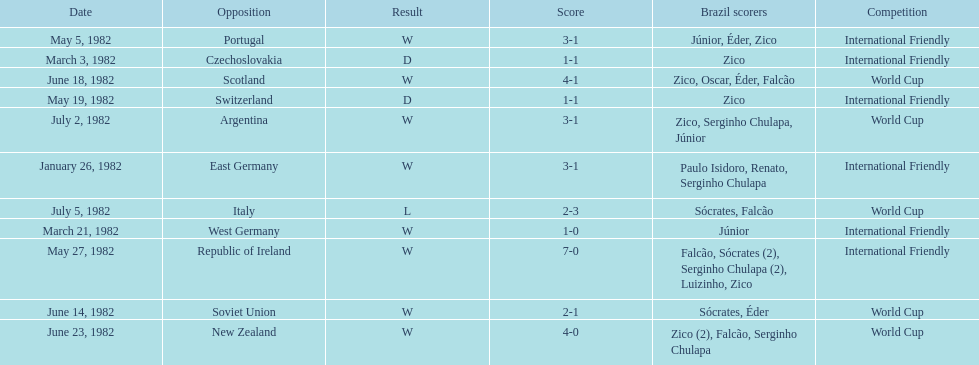Did brazil score more goals against the soviet union or portugal in 1982? Portugal. 